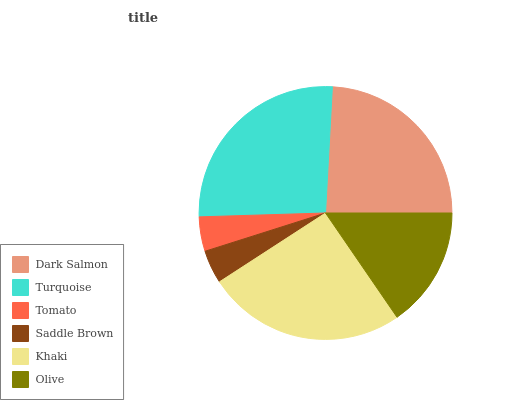Is Saddle Brown the minimum?
Answer yes or no. Yes. Is Turquoise the maximum?
Answer yes or no. Yes. Is Tomato the minimum?
Answer yes or no. No. Is Tomato the maximum?
Answer yes or no. No. Is Turquoise greater than Tomato?
Answer yes or no. Yes. Is Tomato less than Turquoise?
Answer yes or no. Yes. Is Tomato greater than Turquoise?
Answer yes or no. No. Is Turquoise less than Tomato?
Answer yes or no. No. Is Dark Salmon the high median?
Answer yes or no. Yes. Is Olive the low median?
Answer yes or no. Yes. Is Olive the high median?
Answer yes or no. No. Is Dark Salmon the low median?
Answer yes or no. No. 